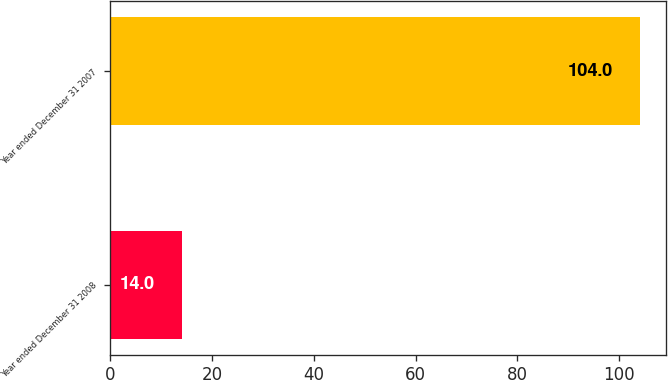<chart> <loc_0><loc_0><loc_500><loc_500><bar_chart><fcel>Year ended December 31 2008<fcel>Year ended December 31 2007<nl><fcel>14<fcel>104<nl></chart> 